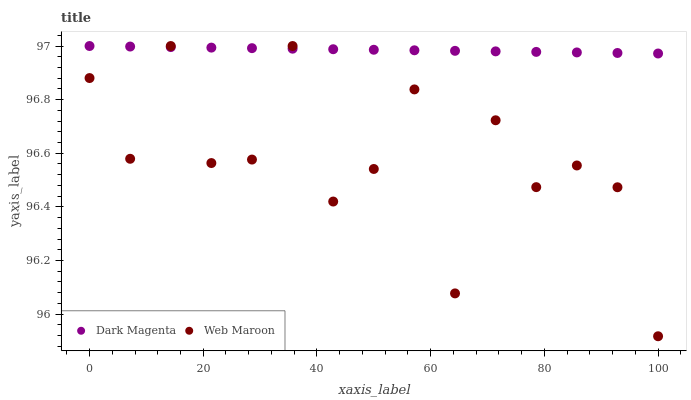Does Web Maroon have the minimum area under the curve?
Answer yes or no. Yes. Does Dark Magenta have the maximum area under the curve?
Answer yes or no. Yes. Does Dark Magenta have the minimum area under the curve?
Answer yes or no. No. Is Dark Magenta the smoothest?
Answer yes or no. Yes. Is Web Maroon the roughest?
Answer yes or no. Yes. Is Dark Magenta the roughest?
Answer yes or no. No. Does Web Maroon have the lowest value?
Answer yes or no. Yes. Does Dark Magenta have the lowest value?
Answer yes or no. No. Does Dark Magenta have the highest value?
Answer yes or no. Yes. Does Web Maroon intersect Dark Magenta?
Answer yes or no. Yes. Is Web Maroon less than Dark Magenta?
Answer yes or no. No. Is Web Maroon greater than Dark Magenta?
Answer yes or no. No. 